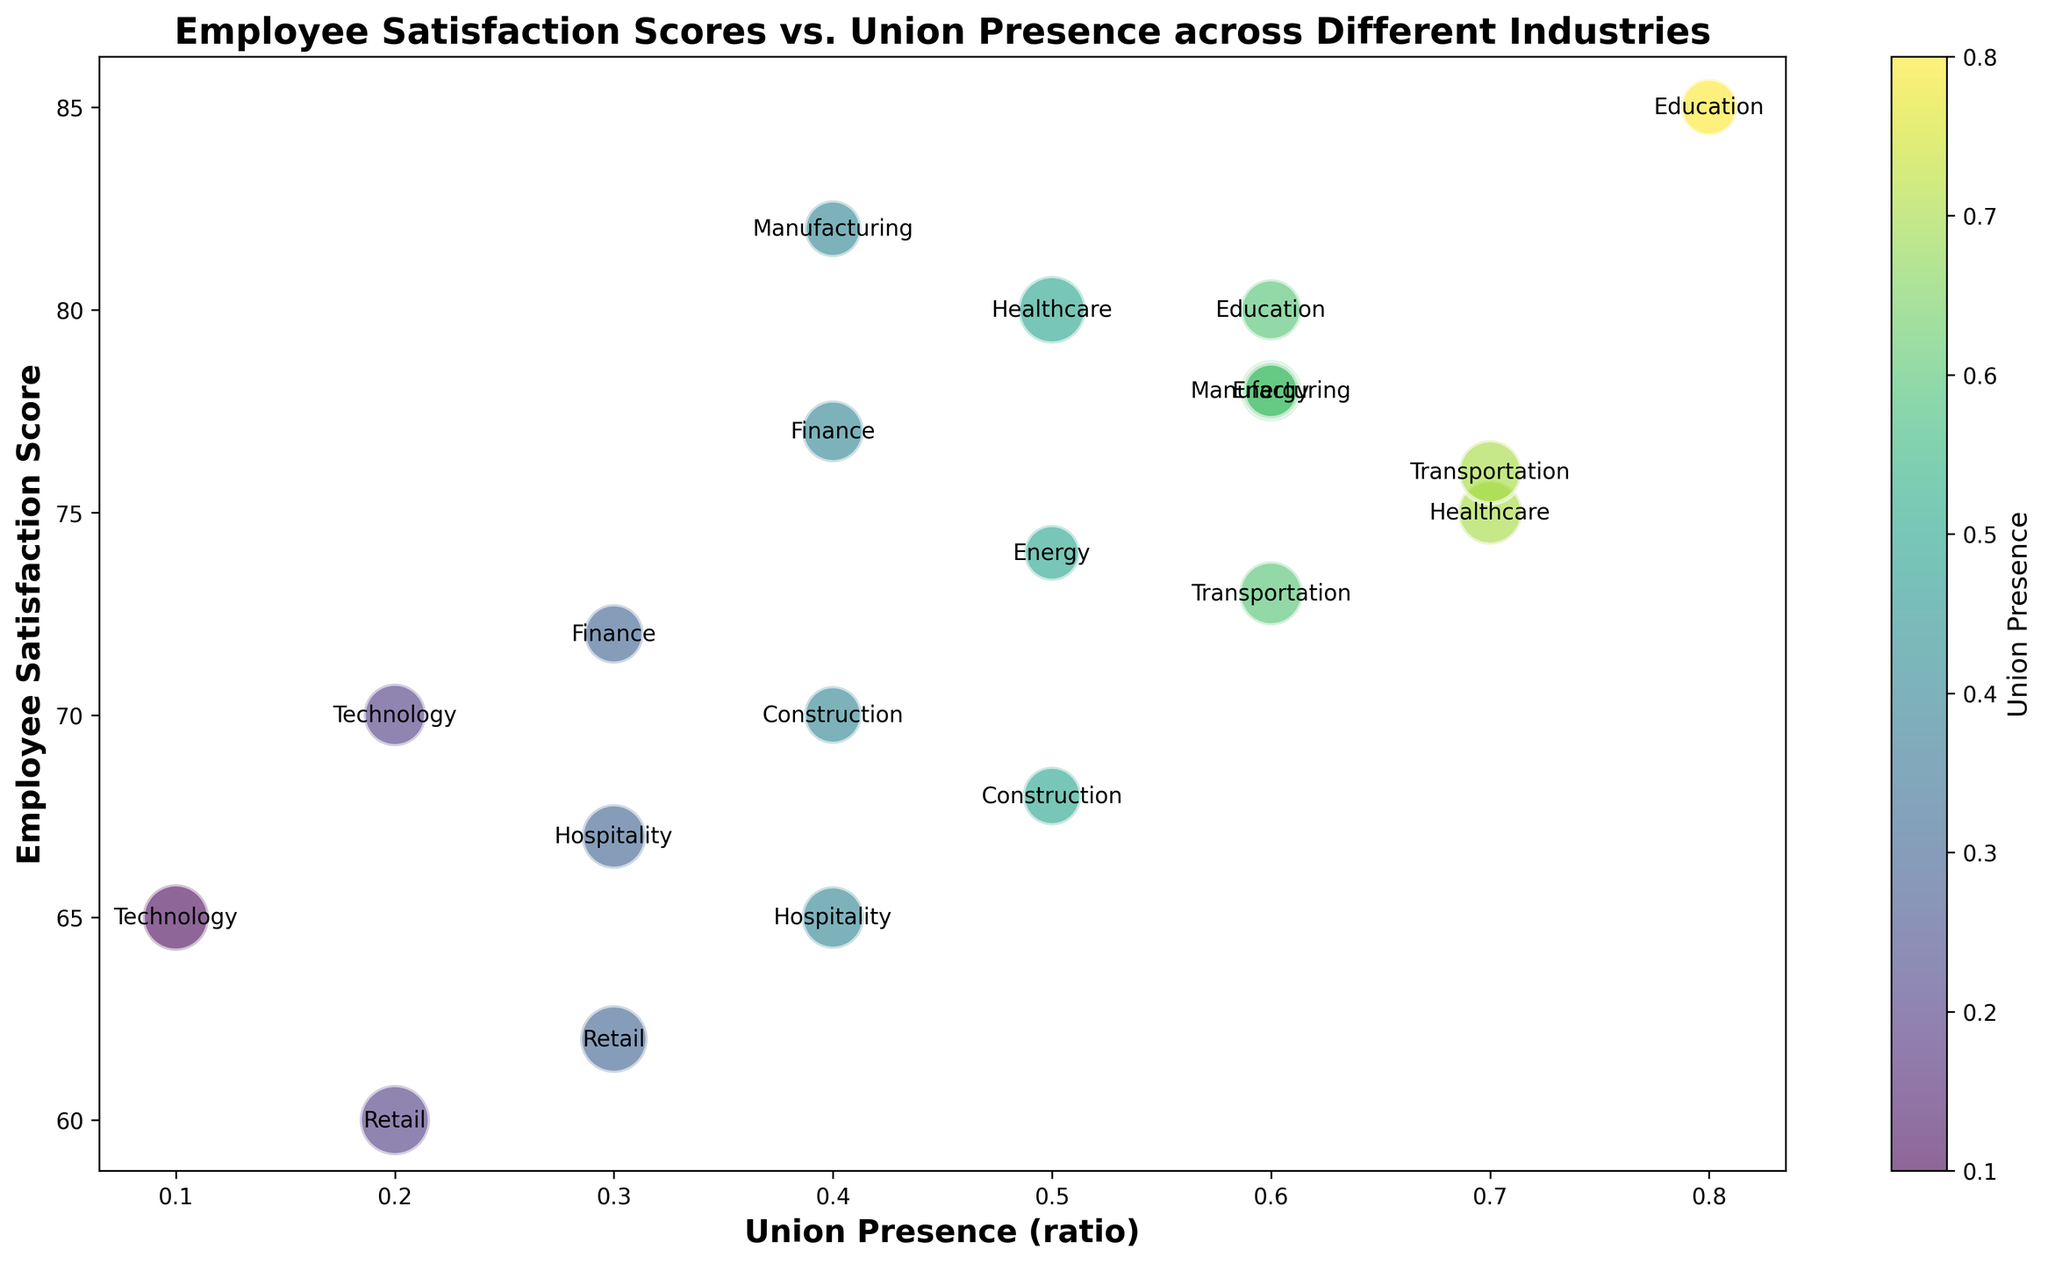What is the relationship between union presence and employee satisfaction in the Education industry? To determine this, locate the Education industry's bubble and observe its position along the Union Presence and Employee Satisfaction Score axes. The bubble shows high union presence (0.8 and 0.6 respectively) and high employee satisfaction scores (85 and 80).
Answer: High union presence correlates with high employee satisfaction Which industry has the highest employee satisfaction score and what is the union presence in that industry? Look for the bubble that is highest on the Employee Satisfaction Score axis. The highest satisfaction score is 85 in the Education industry. The union presence for that bubble is 0.8.
Answer: Education, union presence 0.8 Compare the employee satisfaction scores for the Healthcare and Technology industries. Locate the bubbles for Healthcare and Technology industries and compare their positions along the Employee Satisfaction Score axis. Healthcare has scores of 75 and 80, while Technology has scores of 70 and 65.
Answer: Healthcare is higher (75 and 80 vs 70 and 65) What is the average employee satisfaction score in the Manufacturing industry? Identify the bubbles for the Manufacturing industry and note their satisfaction scores. The scores are 78 and 82. Calculate the average: (78 + 82) / 2 = 160 / 2 = 80.
Answer: 80 Do industries with higher union presence generally have higher employee satisfaction scores? Observe the trend of the bubbles. Bubbles representing high union presence (like Healthcare, Education, Transportation) generally have higher satisfaction scores compared to those with low union presence (like Technology, Retail).
Answer: Yes What is the pattern of union presence in the Retail industry in relation to employee satisfaction scores? Find the Retail industry's bubbles and observe their positions. Retail has union presence values of 0.2 and 0.3 and satisfaction scores of 60 and 62 respectively, showing low employee satisfaction and low union presence.
Answer: Low union presence, low satisfaction Compare the union presence in Manufacturing and Transportation industries. Locate the bubbles representing Manufacturing and Transportation industries. Manufacturing has union presences of 0.6 and 0.4, while Transportation has 0.6 and 0.7.
Answer: Manufacturing 0.6 and 0.4, Transportation 0.6 and 0.7 Do larger bubbles generally indicate higher employee satisfaction scores? Observe the sizes of the bubbles in relation to their positions on the Employee Satisfaction Score axis. Notice if there's any trend between bigger bubbles and higher scores. Larger bubbles (representing more employees) don't necessarily correlate with higher satisfaction scores.
Answer: No Which industry has the lowest employee satisfaction score and what is the union presence in that industry? Locate the bubble that is lowest on the Employee Satisfaction Score axis. The lowest score is 60 in the Retail industry. The union presence for that bubble is 0.2.
Answer: Retail, union presence 0.2 